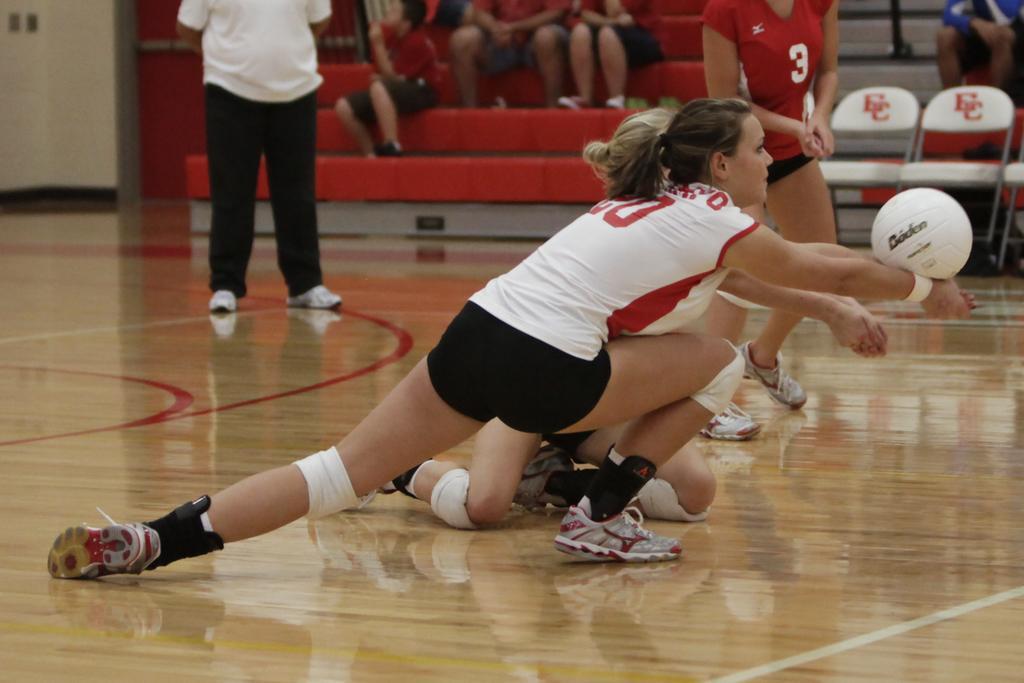Could you give a brief overview of what you see in this image? In this image we can see some people on the floor. On the right side we can see a ball. On the backside we can see a wall, some chairs and a group of people sitting on a staircase. 